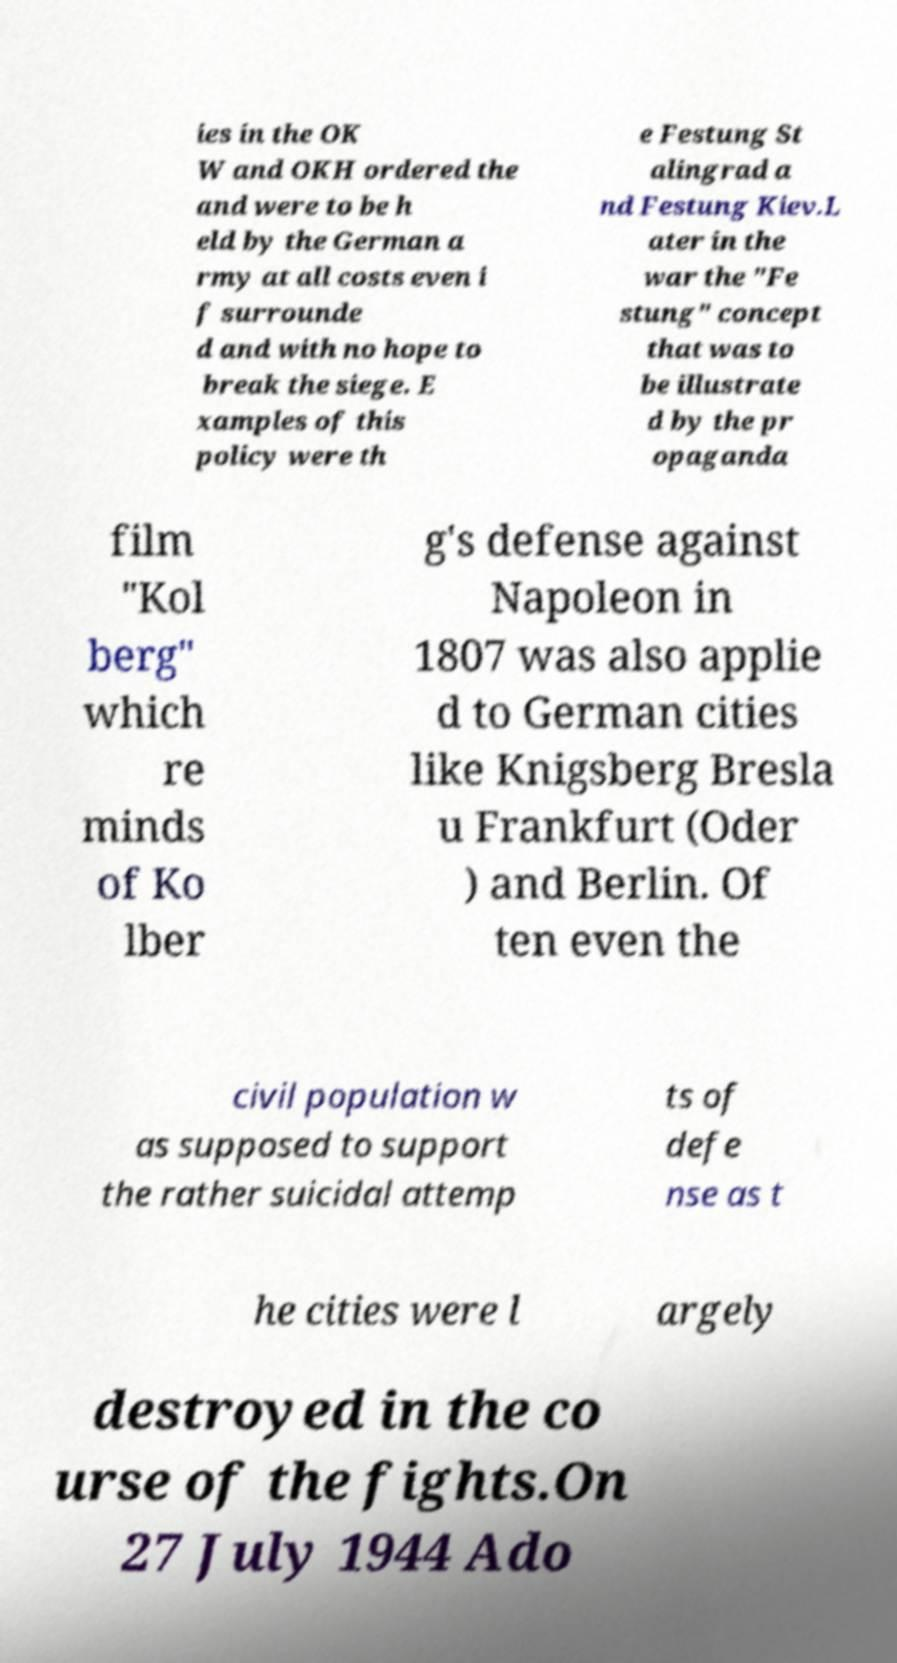There's text embedded in this image that I need extracted. Can you transcribe it verbatim? ies in the OK W and OKH ordered the and were to be h eld by the German a rmy at all costs even i f surrounde d and with no hope to break the siege. E xamples of this policy were th e Festung St alingrad a nd Festung Kiev.L ater in the war the "Fe stung" concept that was to be illustrate d by the pr opaganda film "Kol berg" which re minds of Ko lber g's defense against Napoleon in 1807 was also applie d to German cities like Knigsberg Bresla u Frankfurt (Oder ) and Berlin. Of ten even the civil population w as supposed to support the rather suicidal attemp ts of defe nse as t he cities were l argely destroyed in the co urse of the fights.On 27 July 1944 Ado 